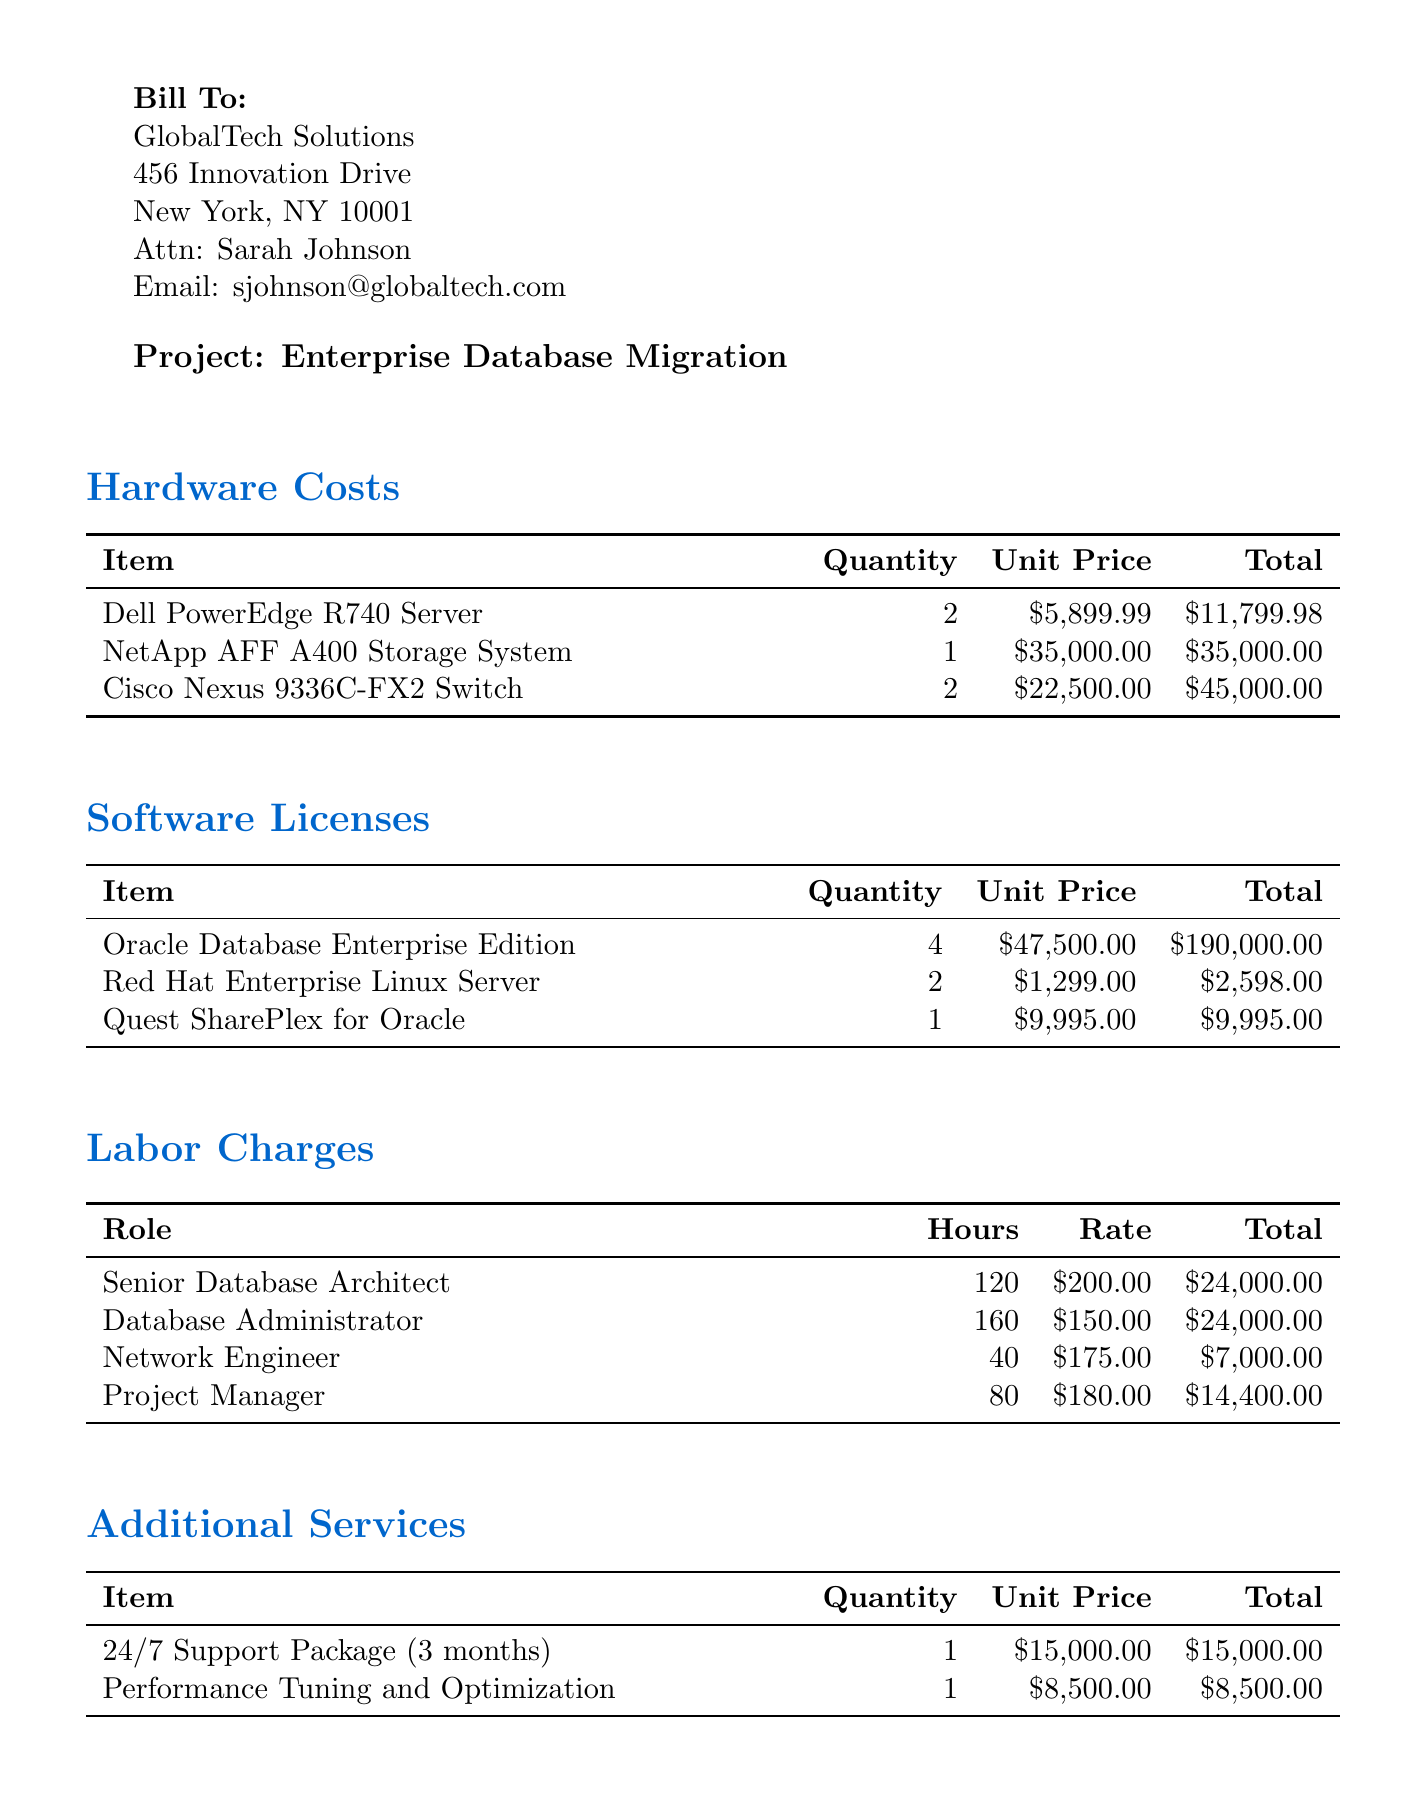What is the invoice number? The invoice number can be found in the document details section, which is specified as "INV-2023-0542."
Answer: INV-2023-0542 What is the total amount due? The total amount due is listed in the summary section, specifically noted as "$420,212.88."
Answer: $420,212.88 Who is the contact person for the client? The contact person for the client is provided in the client info section as "Sarah Johnson."
Answer: Sarah Johnson How many Dell PowerEdge R740 Servers were purchased? The quantity of Dell PowerEdge R740 Servers can be found under hardware costs, which states "2."
Answer: 2 What is the tax rate applied to the invoice? The tax rate can be found in the summary section, stated as "0.085" or 8.5%.
Answer: 0.085 What role did the Network Engineer perform? The role of the Network Engineer is categorized under labor charges, which specifies "Network Engineer."
Answer: Network Engineer What is the unit price of the Oracle Database Enterprise Edition? The unit price for the Oracle Database Enterprise Edition is mentioned in the software licenses section as "$47,500.00."
Answer: $47,500.00 What additional service has a cost of $8,500.00? The additional service costing "$8,500.00" is identified in the additional services section as "Performance Tuning and Optimization."
Answer: Performance Tuning and Optimization What are the payment terms stated in the invoice? The payment terms are explicitly stated in the document as "Net 30."
Answer: Net 30 